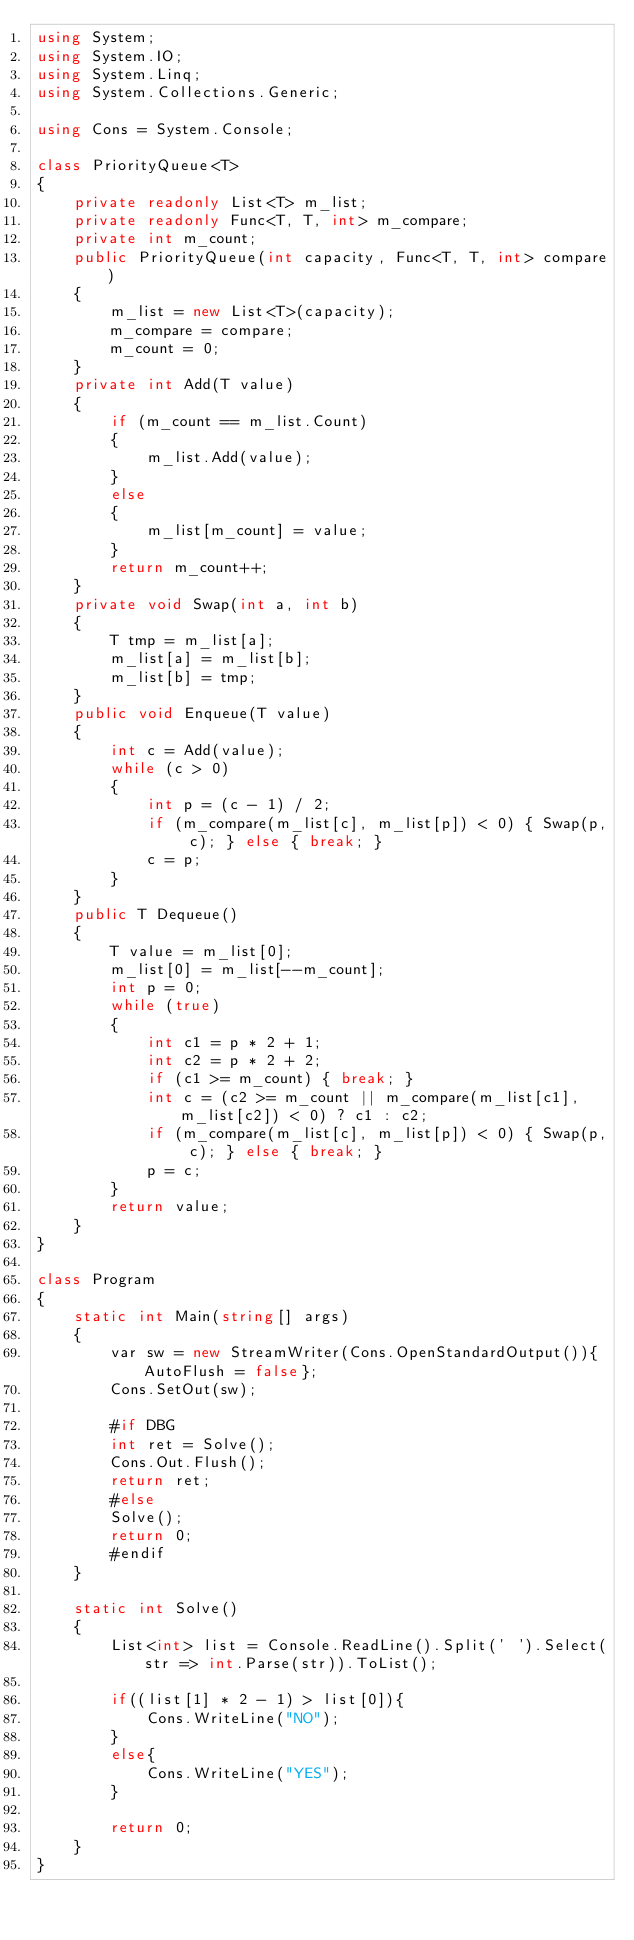<code> <loc_0><loc_0><loc_500><loc_500><_C#_>using System;
using System.IO;
using System.Linq;
using System.Collections.Generic;

using Cons = System.Console;

class PriorityQueue<T>
{
    private readonly List<T> m_list;
    private readonly Func<T, T, int> m_compare;
    private int m_count;
    public PriorityQueue(int capacity, Func<T, T, int> compare)
    {
        m_list = new List<T>(capacity);
        m_compare = compare;
        m_count = 0;
    }
    private int Add(T value)
    {
        if (m_count == m_list.Count)
        {
            m_list.Add(value);
        }
        else
        {
            m_list[m_count] = value;
        }
        return m_count++;
    }
    private void Swap(int a, int b)
    {
        T tmp = m_list[a];
        m_list[a] = m_list[b];
        m_list[b] = tmp;
    }
    public void Enqueue(T value)
    {
        int c = Add(value);
        while (c > 0)
        {
            int p = (c - 1) / 2;
            if (m_compare(m_list[c], m_list[p]) < 0) { Swap(p, c); } else { break; }
            c = p;
        }
    }
    public T Dequeue()
    {
        T value = m_list[0];
        m_list[0] = m_list[--m_count];
        int p = 0;
        while (true)
        {
            int c1 = p * 2 + 1;
            int c2 = p * 2 + 2;
            if (c1 >= m_count) { break; }
            int c = (c2 >= m_count || m_compare(m_list[c1], m_list[c2]) < 0) ? c1 : c2;
            if (m_compare(m_list[c], m_list[p]) < 0) { Swap(p, c); } else { break; }
            p = c;
        }
        return value;
    }
}

class Program
{
    static int Main(string[] args)
    {
        var sw = new StreamWriter(Cons.OpenStandardOutput()){AutoFlush = false};
        Cons.SetOut(sw);
        
        #if DBG
        int ret = Solve();
        Cons.Out.Flush();
        return ret;
        #else
        Solve();
        return 0;
        #endif
    }

    static int Solve()
    {
        List<int> list = Console.ReadLine().Split(' ').Select(str => int.Parse(str)).ToList();

        if((list[1] * 2 - 1) > list[0]){
            Cons.WriteLine("NO");
        }
        else{
            Cons.WriteLine("YES");
        }

        return 0;
    }
}</code> 